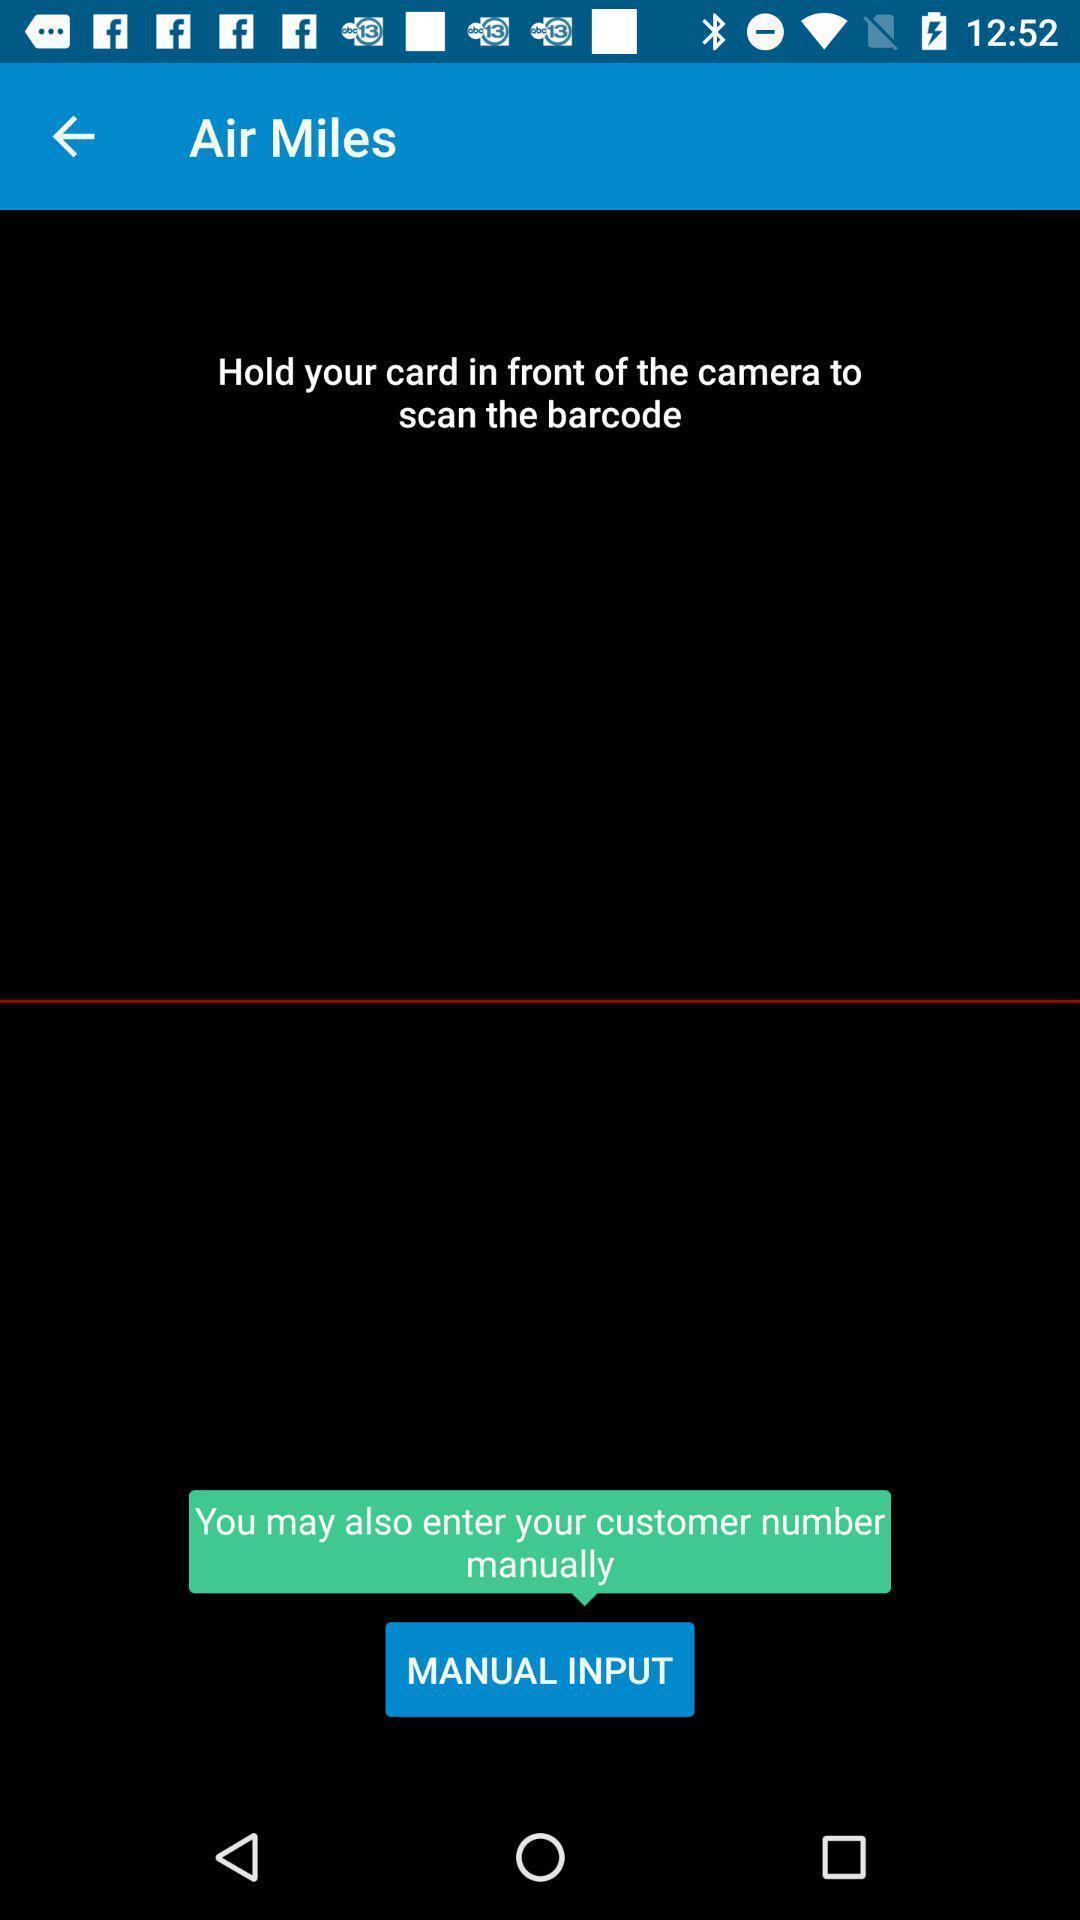Describe the key features of this screenshot. Screen showing page with manual input option. 